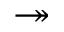<formula> <loc_0><loc_0><loc_500><loc_500>\twoheadrightarrow</formula> 